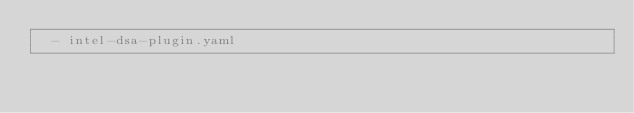<code> <loc_0><loc_0><loc_500><loc_500><_YAML_>  - intel-dsa-plugin.yaml
</code> 